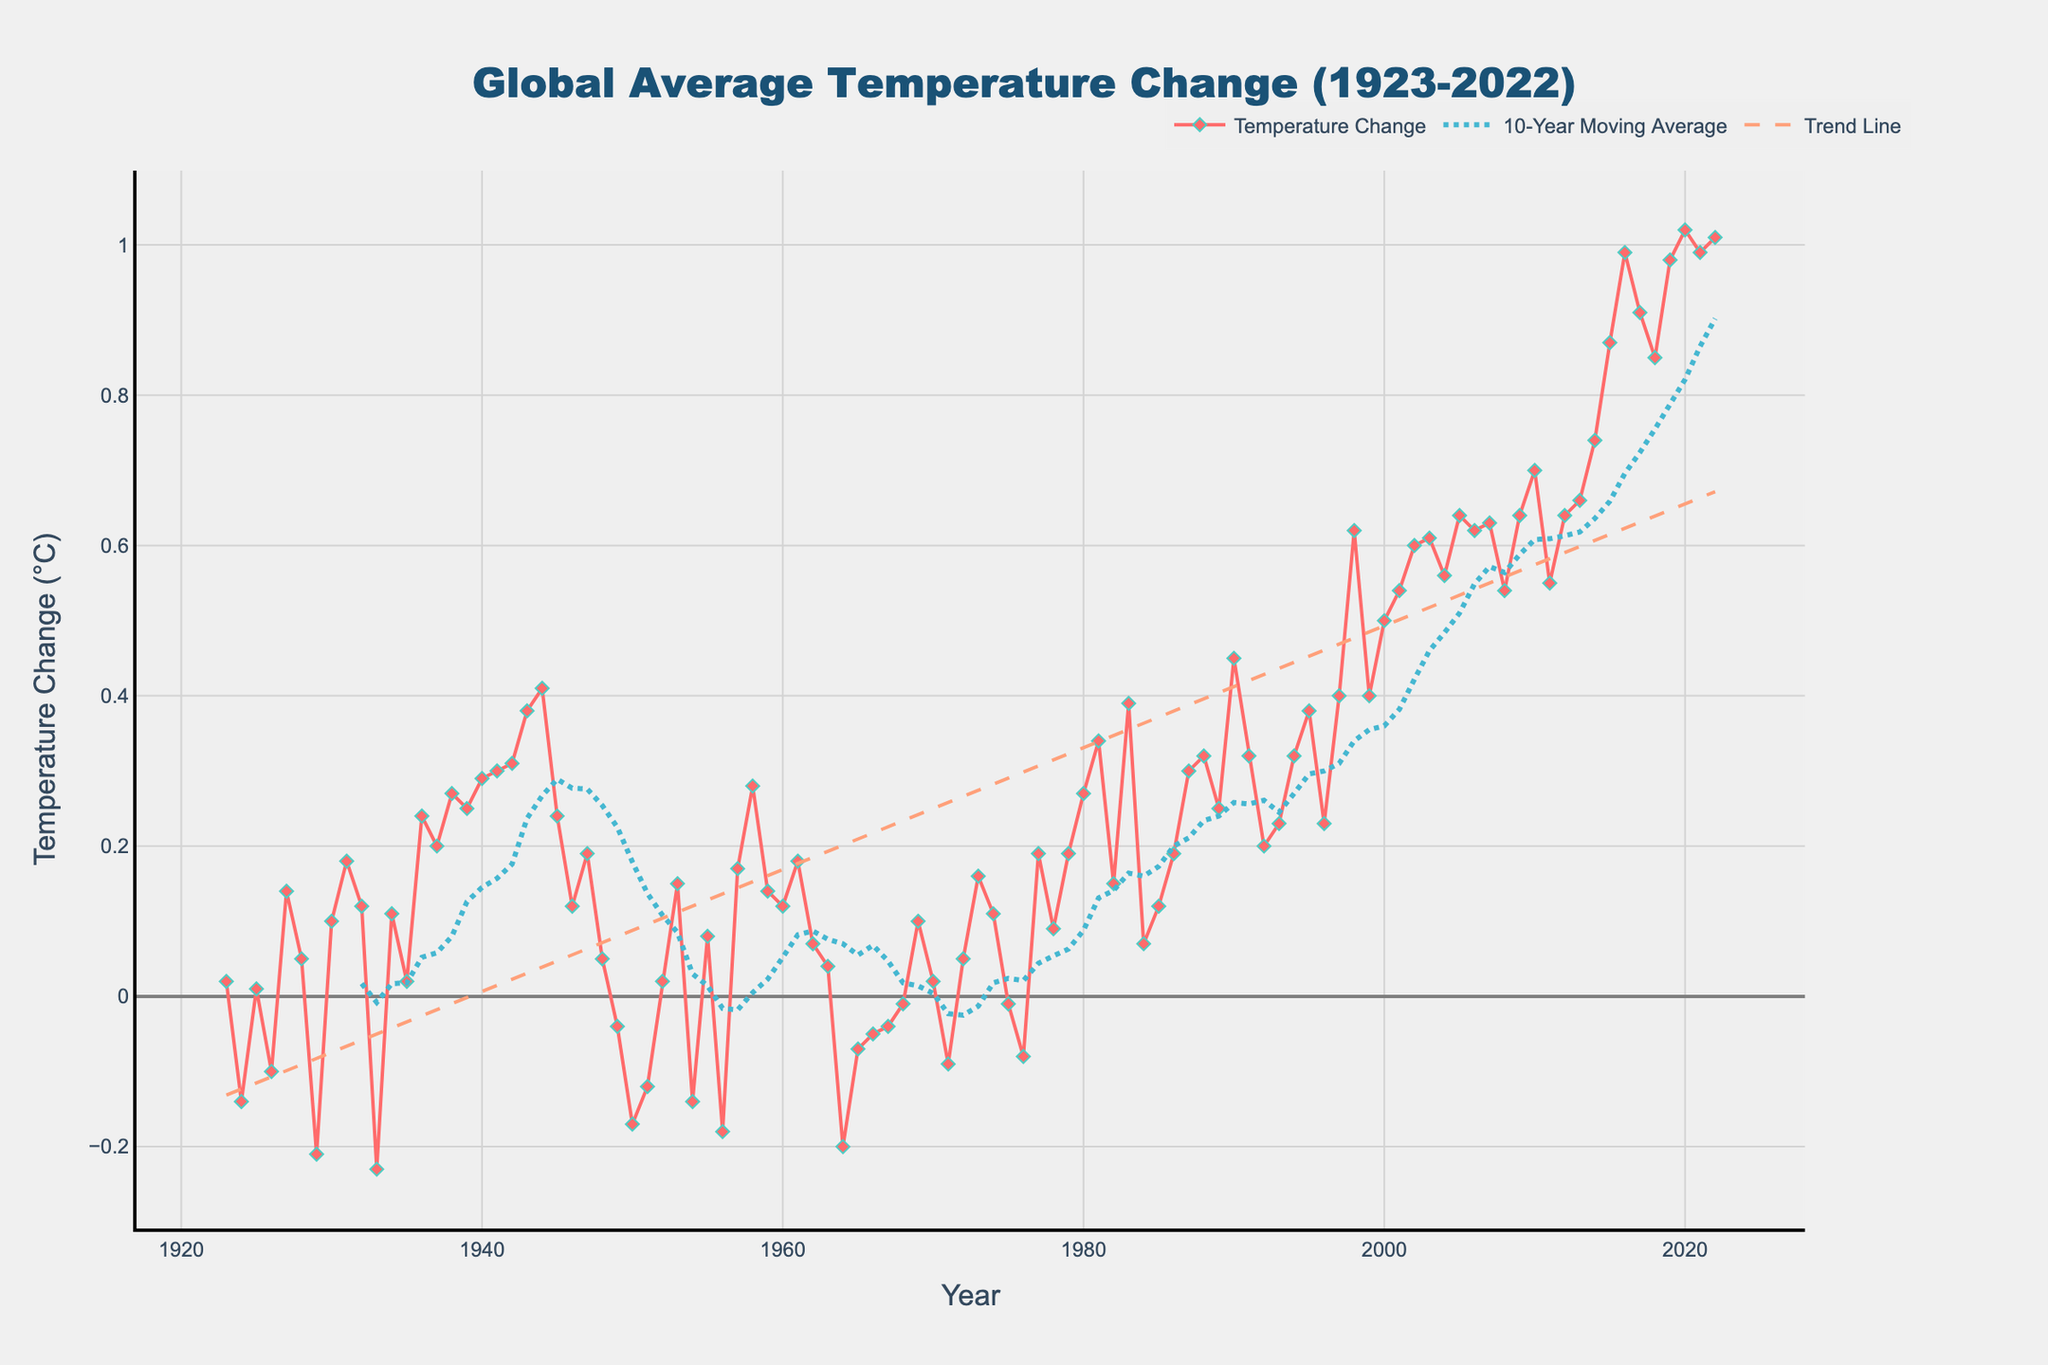What is the title of the plot? The title appears at the top of the plot and it describes the main subject of the figure. It reads "Global Average Temperature Change (1923-2022)" as it summarizes the visual data presented.
Answer: Global Average Temperature Change (1923-2022) What is the y-axis label on the left side of the plot? The y-axis label indicates the quantity being measured on the vertical axis. In this case, it is "Temperature Change (°C)," specifying the global average temperature change in degrees Celsius.
Answer: Temperature Change (°C) What is the trend of the global average temperature change over the past century? By examining the trend line in the plot, which is drawn as a dashed line, we can see that the global average temperature has consistently increased over the past century. The slope of the trend line indicates this upward trend.
Answer: Increasing Which year had the highest recorded global average temperature change? To find the year with the highest recorded temperature change, identify the peak of the time series plot. The point at the highest vertical position represents the year 2020 with a value of 1.02°C.
Answer: 2020 What is the 10-year moving average temperature change in the year 1950? Find the data point of the 10-year moving average line for the year 1950. This can be read directly from the graph from the line in aqua color. The value is around -0.14°C.
Answer: -0.14°C How does the temperature change in 1940 compare to that in 1980? To compare the temperature changes, locate both years on the x-axis and compare the y-values. 1940 had a change of 0.29°C and 1980 had a change of 0.27°C.
Answer: 0.29°C is higher than 0.27°C How many times did the global average temperature decrease compared to the previous year? Count the points where the temperature change value drops from one year to the next, indicated by the points connected by downward sloping lines.
Answer: 14 What was the approximate global average temperature change around the year 1977? Look at the data point corresponding to the year 1977 on the x-axis and find its y-value. The approximate temperature change is around 0.19°C.
Answer: 0.19°C Which decade had the most significant increase in global average temperature change? To determine the decade with the most significant increase, look at the slope of the plot over different decades. The 2010s show the steepest rise in temperature change, reaching above 0.90°C.
Answer: 2010s What is the difference in temperature change between the highest and lowest points on the graph? Identify the highest value (1.02°C in 2020) and the lowest value (-0.23°C in 1933) and subtract the lowest from the highest. 1.02°C - (-0.23°C) = 1.25°C.
Answer: 1.25°C 